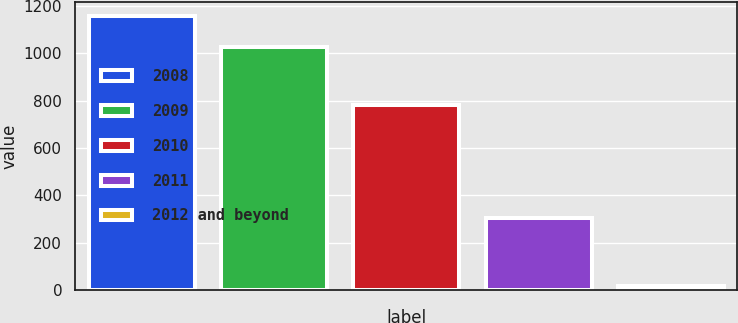Convert chart to OTSL. <chart><loc_0><loc_0><loc_500><loc_500><bar_chart><fcel>2008<fcel>2009<fcel>2010<fcel>2011<fcel>2012 and beyond<nl><fcel>1157<fcel>1024<fcel>780<fcel>306<fcel>20<nl></chart> 